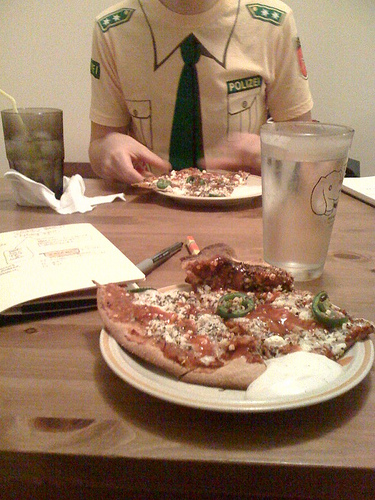What might be the overall mood or atmosphere based on the image? The image conveys a casual and relaxed atmosphere, as it appears to be a simple meal at home. The informality of the dining setup and the partially eaten pizza suggest a laid-back environment. 